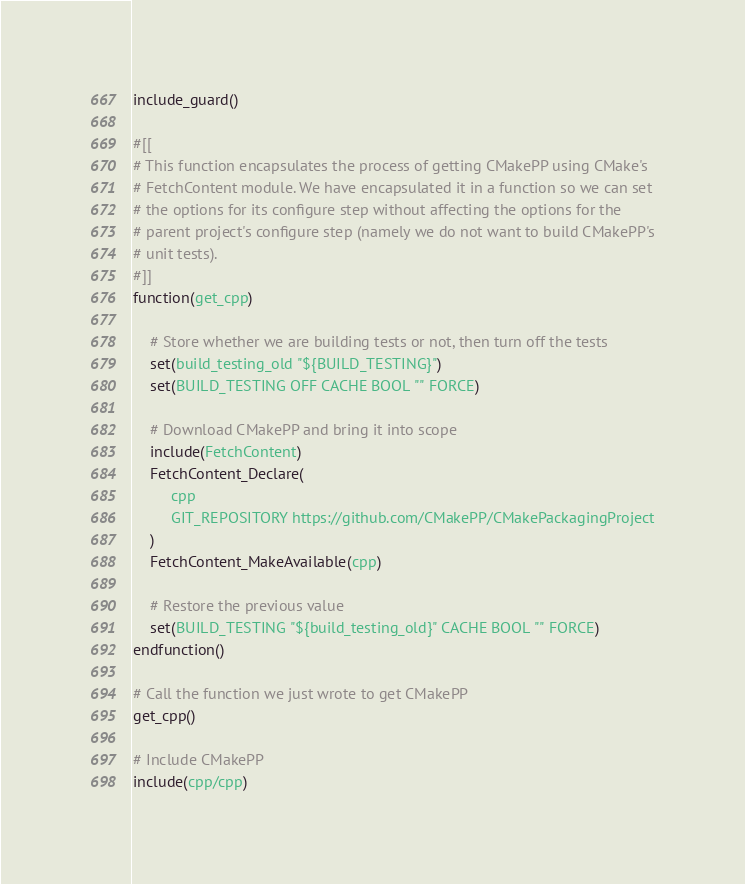Convert code to text. <code><loc_0><loc_0><loc_500><loc_500><_CMake_>include_guard()

#[[
# This function encapsulates the process of getting CMakePP using CMake's
# FetchContent module. We have encapsulated it in a function so we can set
# the options for its configure step without affecting the options for the
# parent project's configure step (namely we do not want to build CMakePP's
# unit tests).
#]]
function(get_cpp)

    # Store whether we are building tests or not, then turn off the tests
    set(build_testing_old "${BUILD_TESTING}")
    set(BUILD_TESTING OFF CACHE BOOL "" FORCE)

    # Download CMakePP and bring it into scope
    include(FetchContent)
    FetchContent_Declare(
         cpp
         GIT_REPOSITORY https://github.com/CMakePP/CMakePackagingProject
    )
    FetchContent_MakeAvailable(cpp)

    # Restore the previous value
    set(BUILD_TESTING "${build_testing_old}" CACHE BOOL "" FORCE)
endfunction()

# Call the function we just wrote to get CMakePP
get_cpp()

# Include CMakePP
include(cpp/cpp)</code> 